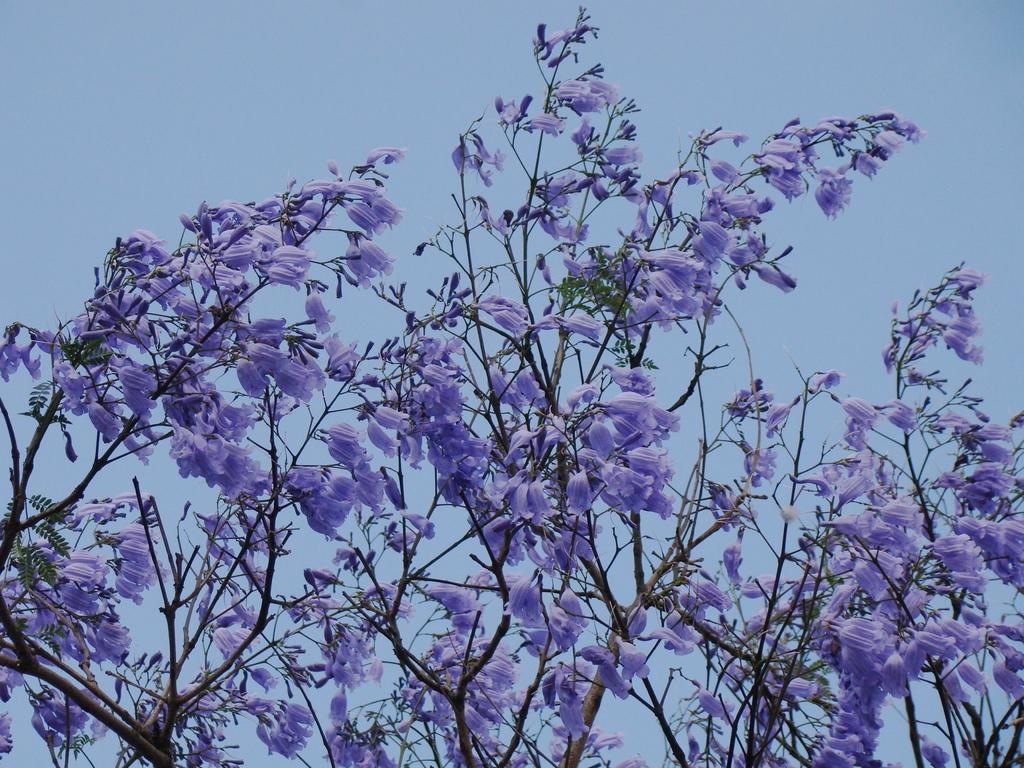What type of flowers can be seen in the image? There are purple color flowers in the image. What else can be seen on the tree besides the flowers? There are leaves on the tree in the image. What is visible at the top of the image? The sky is visible at the top of the image. How much money is being exchanged between the flowers in the image? There is no money being exchanged in the image; it features flowers and leaves on a tree. What type of division can be seen among the flowers in the image? There is no division among the flowers in the image; they are all part of the same tree. 